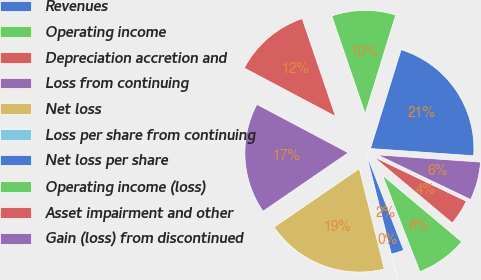Convert chart to OTSL. <chart><loc_0><loc_0><loc_500><loc_500><pie_chart><fcel>Revenues<fcel>Operating income<fcel>Depreciation accretion and<fcel>Loss from continuing<fcel>Net loss<fcel>Loss per share from continuing<fcel>Net loss per share<fcel>Operating income (loss)<fcel>Asset impairment and other<fcel>Gain (loss) from discontinued<nl><fcel>21.33%<fcel>10.01%<fcel>12.01%<fcel>17.32%<fcel>19.32%<fcel>0.0%<fcel>2.0%<fcel>8.0%<fcel>4.0%<fcel>6.0%<nl></chart> 